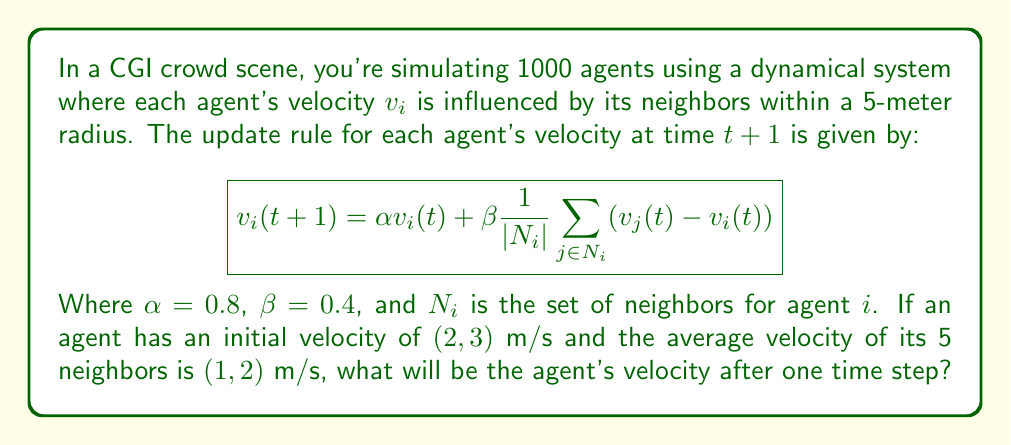Give your solution to this math problem. Let's approach this step-by-step:

1) We're given the update rule:
   $$v_i(t+1) = \alpha v_i(t) + \beta \frac{1}{|N_i|} \sum_{j \in N_i} (v_j(t) - v_i(t))$$

2) We know:
   - $\alpha = 0.8$
   - $\beta = 0.4$
   - $v_i(t) = (2, 3)$
   - Average velocity of neighbors $\frac{1}{|N_i|} \sum_{j \in N_i} v_j(t) = (1, 2)$
   - $|N_i| = 5$ (number of neighbors)

3) Let's substitute these into the equation:
   $$v_i(t+1) = 0.8(2, 3) + 0.4((1, 2) - (2, 3))$$

4) Simplify the first term:
   $$v_i(t+1) = (1.6, 2.4) + 0.4((1, 2) - (2, 3))$$

5) Simplify the subtraction inside the parentheses:
   $$v_i(t+1) = (1.6, 2.4) + 0.4(-1, -1)$$

6) Multiply the second term:
   $$v_i(t+1) = (1.6, 2.4) + (-0.4, -0.4)$$

7) Add the vectors:
   $$v_i(t+1) = (1.2, 2.0)$$

Therefore, after one time step, the agent's velocity will be (1.2, 2.0) m/s.
Answer: (1.2, 2.0) m/s 